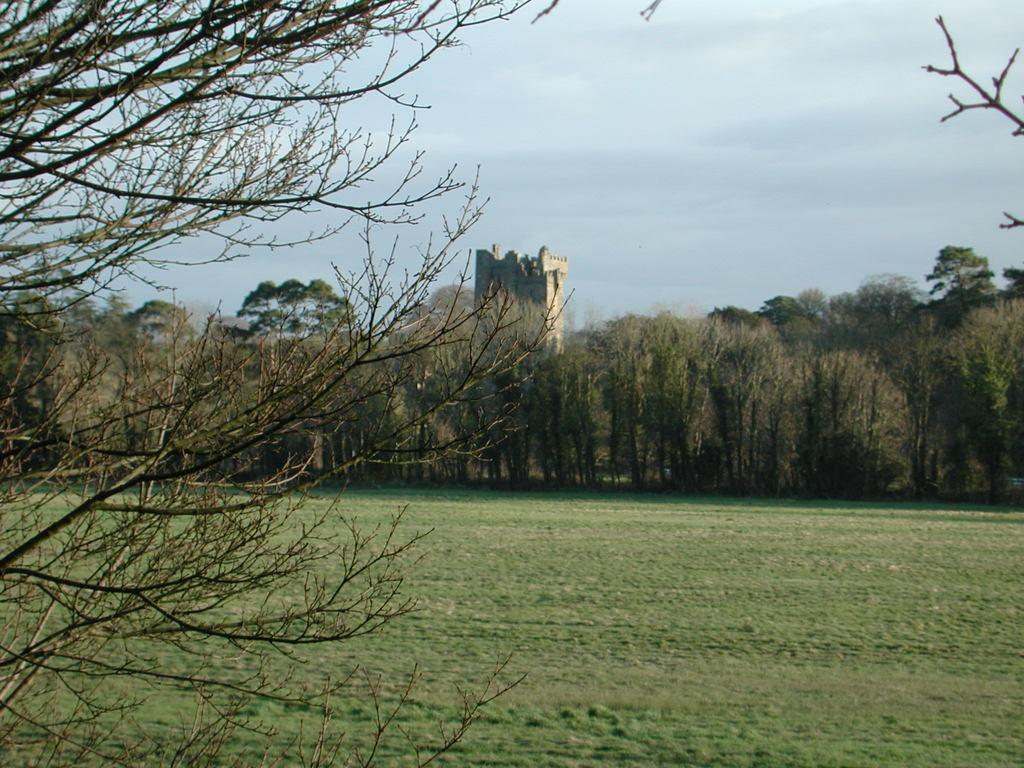What type of vegetation is at the bottom of the image? There is grass at the bottom of the image. What can be seen in the middle of the image? There are trees and a castle in the middle of the image. What is visible at the top of the image? Clouds and the sky are visible at the top of the image. How many clovers are present in the image? There is no mention of clovers in the image, so it is impossible to determine their presence or quantity. What type of love is depicted in the image? There is no depiction of love in the image; it features grass, trees, a castle, clouds, and the sky. 